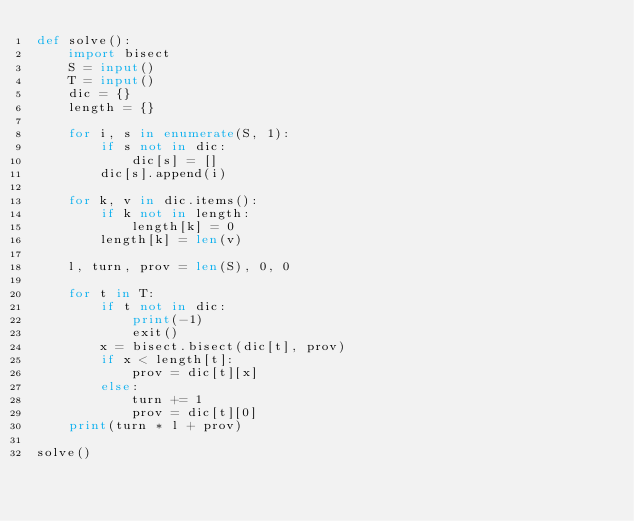<code> <loc_0><loc_0><loc_500><loc_500><_Python_>def solve():
    import bisect
    S = input()
    T = input()
    dic = {}
    length = {}

    for i, s in enumerate(S, 1):
        if s not in dic:
            dic[s] = []
        dic[s].append(i)

    for k, v in dic.items():
        if k not in length:
            length[k] = 0
        length[k] = len(v)

    l, turn, prov = len(S), 0, 0

    for t in T:
        if t not in dic:
            print(-1)
            exit()
        x = bisect.bisect(dic[t], prov)
        if x < length[t]:
            prov = dic[t][x]
        else:
            turn += 1
            prov = dic[t][0]
    print(turn * l + prov)

solve()

</code> 